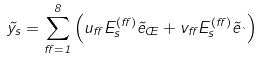<formula> <loc_0><loc_0><loc_500><loc_500>\vec { y } _ { s } = \sum _ { \alpha = 1 } ^ { 8 } \left ( u _ { \alpha } E ^ { ( \alpha ) } _ { s } \vec { e } _ { \phi } + v _ { \alpha } E ^ { ( \alpha ) } _ { s } \vec { e } _ { \theta } \right )</formula> 